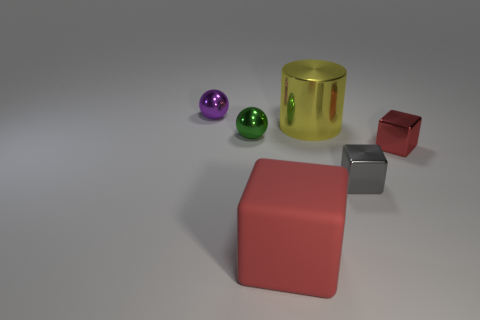How many large matte cubes are the same color as the metal cylinder?
Provide a succinct answer. 0. There is a gray thing that is the same size as the purple metallic thing; what is its shape?
Give a very brief answer. Cube. Is there another object of the same size as the green metal object?
Make the answer very short. Yes. There is a gray thing that is the same size as the green metallic ball; what is its material?
Your answer should be very brief. Metal. There is a red cube that is behind the block that is left of the cylinder; what size is it?
Provide a short and direct response. Small. Do the gray thing to the right of the green sphere and the large yellow metallic thing have the same size?
Offer a very short reply. No. Are there more red matte objects left of the small purple object than tiny purple shiny balls in front of the small green ball?
Give a very brief answer. No. The shiny object that is both right of the big cylinder and to the left of the tiny red shiny cube has what shape?
Ensure brevity in your answer.  Cube. What shape is the small red object behind the red matte object?
Provide a succinct answer. Cube. What is the size of the metallic sphere that is left of the sphere that is in front of the purple ball left of the gray block?
Offer a very short reply. Small. 